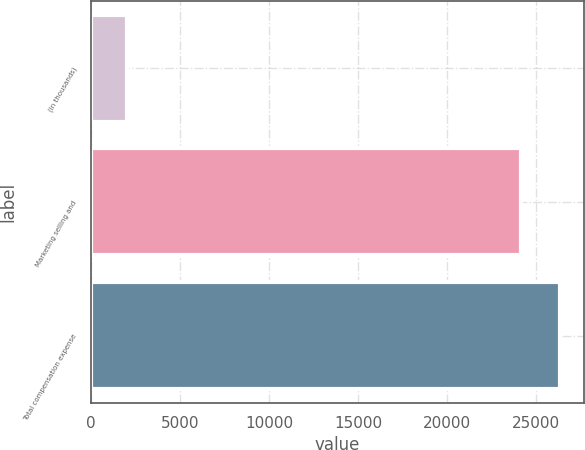<chart> <loc_0><loc_0><loc_500><loc_500><bar_chart><fcel>(In thousands)<fcel>Marketing selling and<fcel>Total compensation expense<nl><fcel>2012<fcel>24153<fcel>26367.1<nl></chart> 